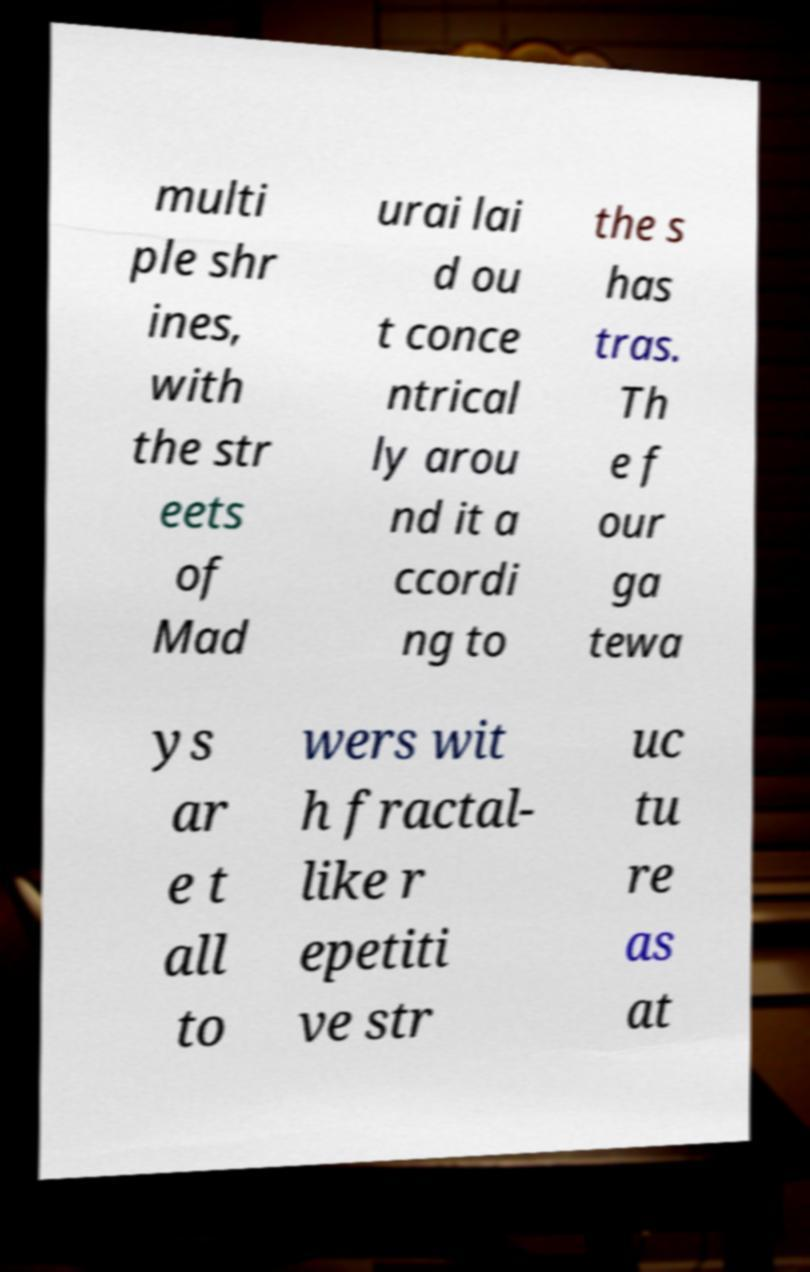There's text embedded in this image that I need extracted. Can you transcribe it verbatim? multi ple shr ines, with the str eets of Mad urai lai d ou t conce ntrical ly arou nd it a ccordi ng to the s has tras. Th e f our ga tewa ys ar e t all to wers wit h fractal- like r epetiti ve str uc tu re as at 